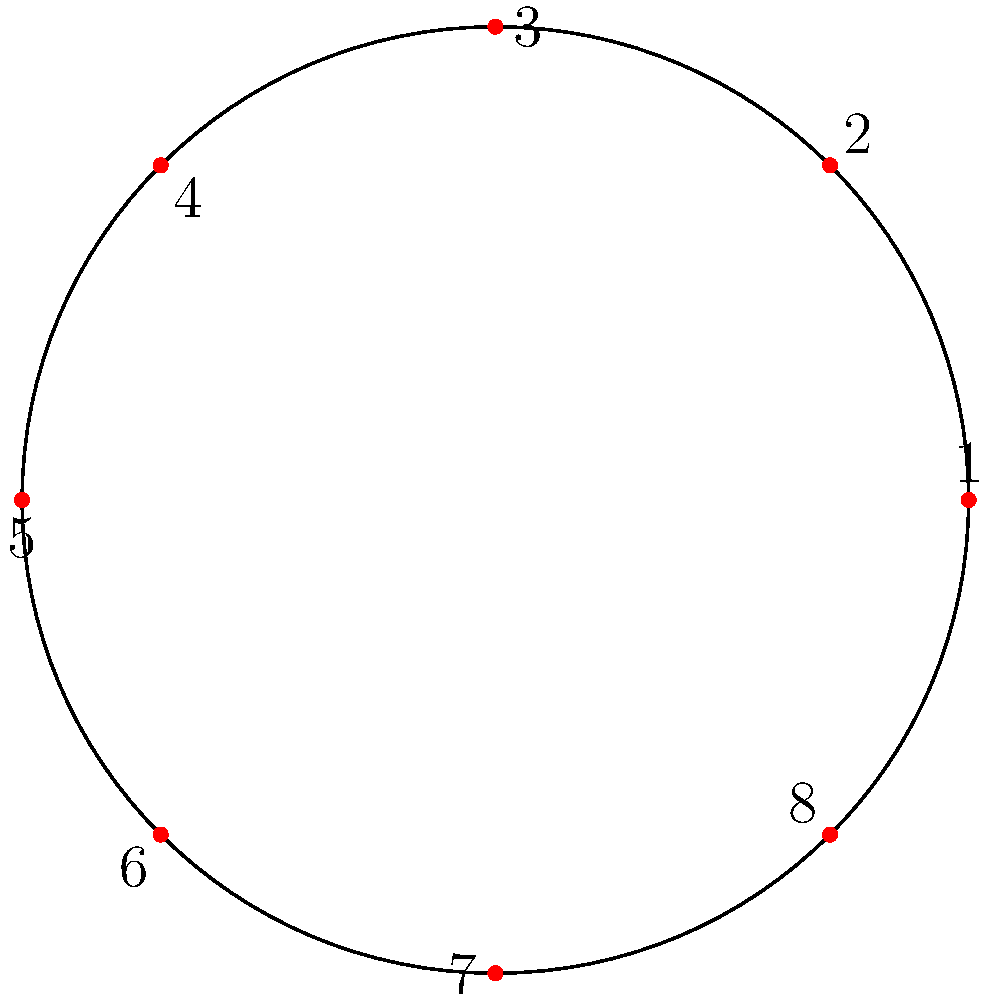In a rugby scrum formation, 8 players are arranged in a circular pattern as shown in the diagram. Let $G$ be the cyclic group generated by the clockwise rotation $r$ that moves each player to the position of the next player (e.g., 1 → 2, 2 → 3, ..., 8 → 1). What is the order of the group $G$? To determine the order of the cyclic group $G$, we need to follow these steps:

1) First, recall that the order of a cyclic group is the smallest positive integer $n$ such that $r^n = e$ (the identity element).

2) In this case, $r$ represents a clockwise rotation by one position.

3) Let's see what happens when we apply $r$ multiple times:
   $r^1$: (1 → 2, 2 → 3, ..., 8 → 1)
   $r^2$: (1 → 3, 2 → 4, ..., 8 → 2)
   $r^3$: (1 → 4, 2 → 5, ..., 8 → 3)
   ...

4) We need to find the smallest number of rotations that brings all players back to their original positions.

5) Since there are 8 players in the formation, after 8 rotations, each player will have moved 8 positions clockwise, returning to their starting position.

6) Therefore, $r^8 = e$ (the identity permutation).

7) This is the smallest positive integer $n$ for which $r^n = e$.

Thus, the order of the cyclic group $G$ is 8.
Answer: 8 